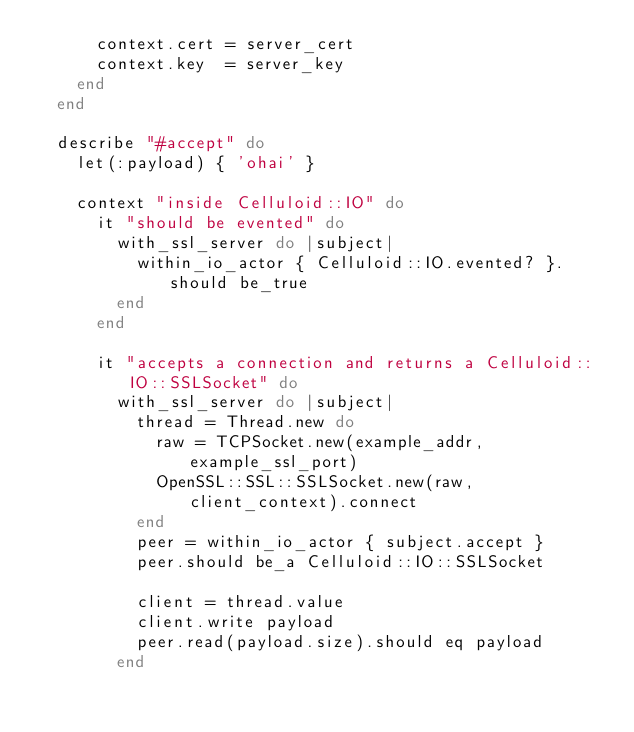Convert code to text. <code><loc_0><loc_0><loc_500><loc_500><_Ruby_>      context.cert = server_cert
      context.key  = server_key
    end
  end

  describe "#accept" do
    let(:payload) { 'ohai' }

    context "inside Celluloid::IO" do
      it "should be evented" do
        with_ssl_server do |subject|
          within_io_actor { Celluloid::IO.evented? }.should be_true
        end
      end

      it "accepts a connection and returns a Celluloid::IO::SSLSocket" do
        with_ssl_server do |subject|
          thread = Thread.new do
            raw = TCPSocket.new(example_addr, example_ssl_port)
            OpenSSL::SSL::SSLSocket.new(raw, client_context).connect
          end
          peer = within_io_actor { subject.accept }
          peer.should be_a Celluloid::IO::SSLSocket

          client = thread.value
          client.write payload
          peer.read(payload.size).should eq payload
        end</code> 